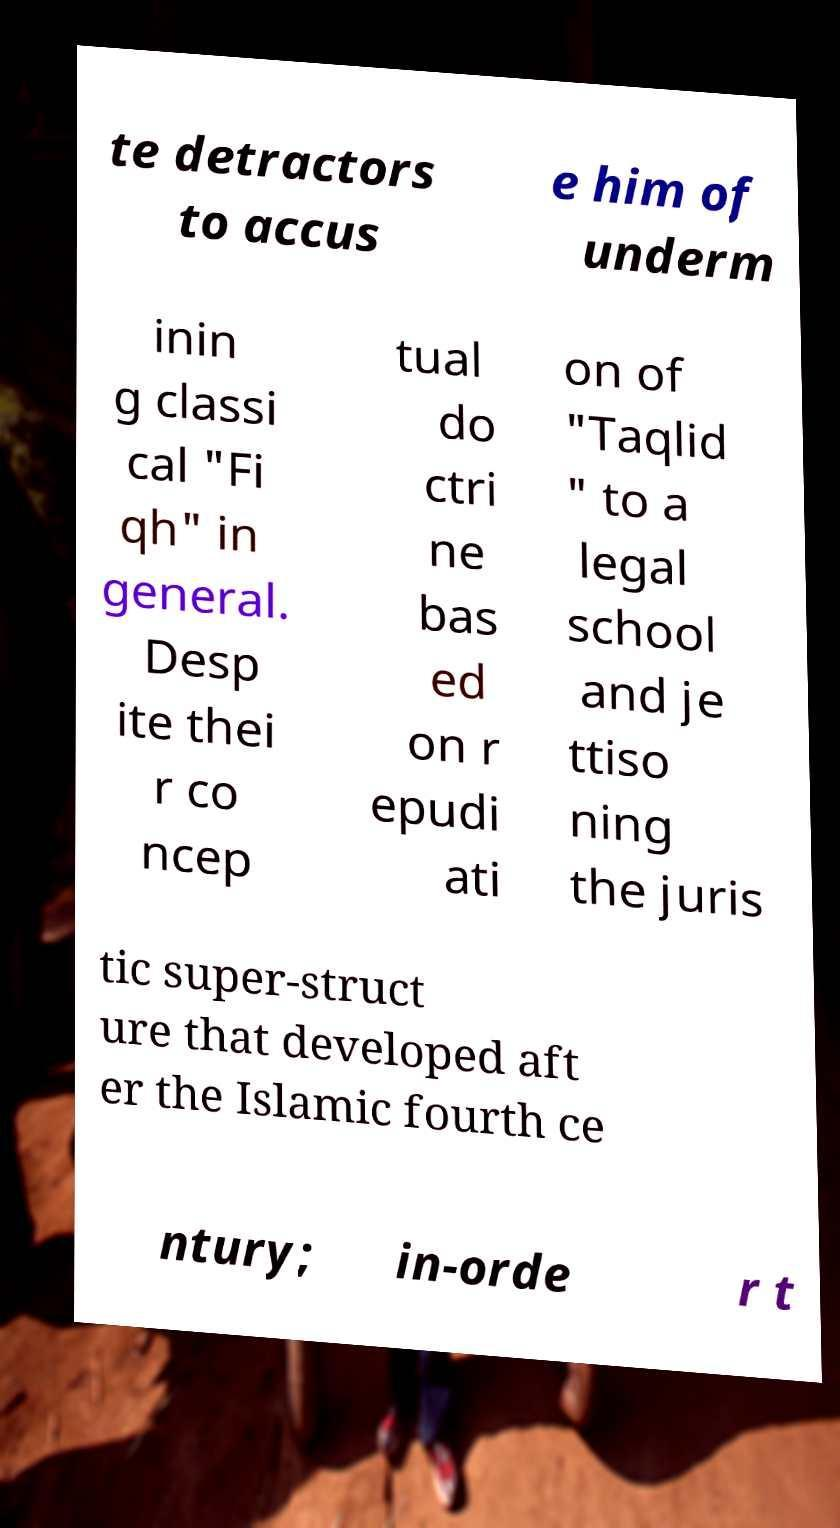What messages or text are displayed in this image? I need them in a readable, typed format. te detractors to accus e him of underm inin g classi cal "Fi qh" in general. Desp ite thei r co ncep tual do ctri ne bas ed on r epudi ati on of "Taqlid " to a legal school and je ttiso ning the juris tic super-struct ure that developed aft er the Islamic fourth ce ntury; in-orde r t 